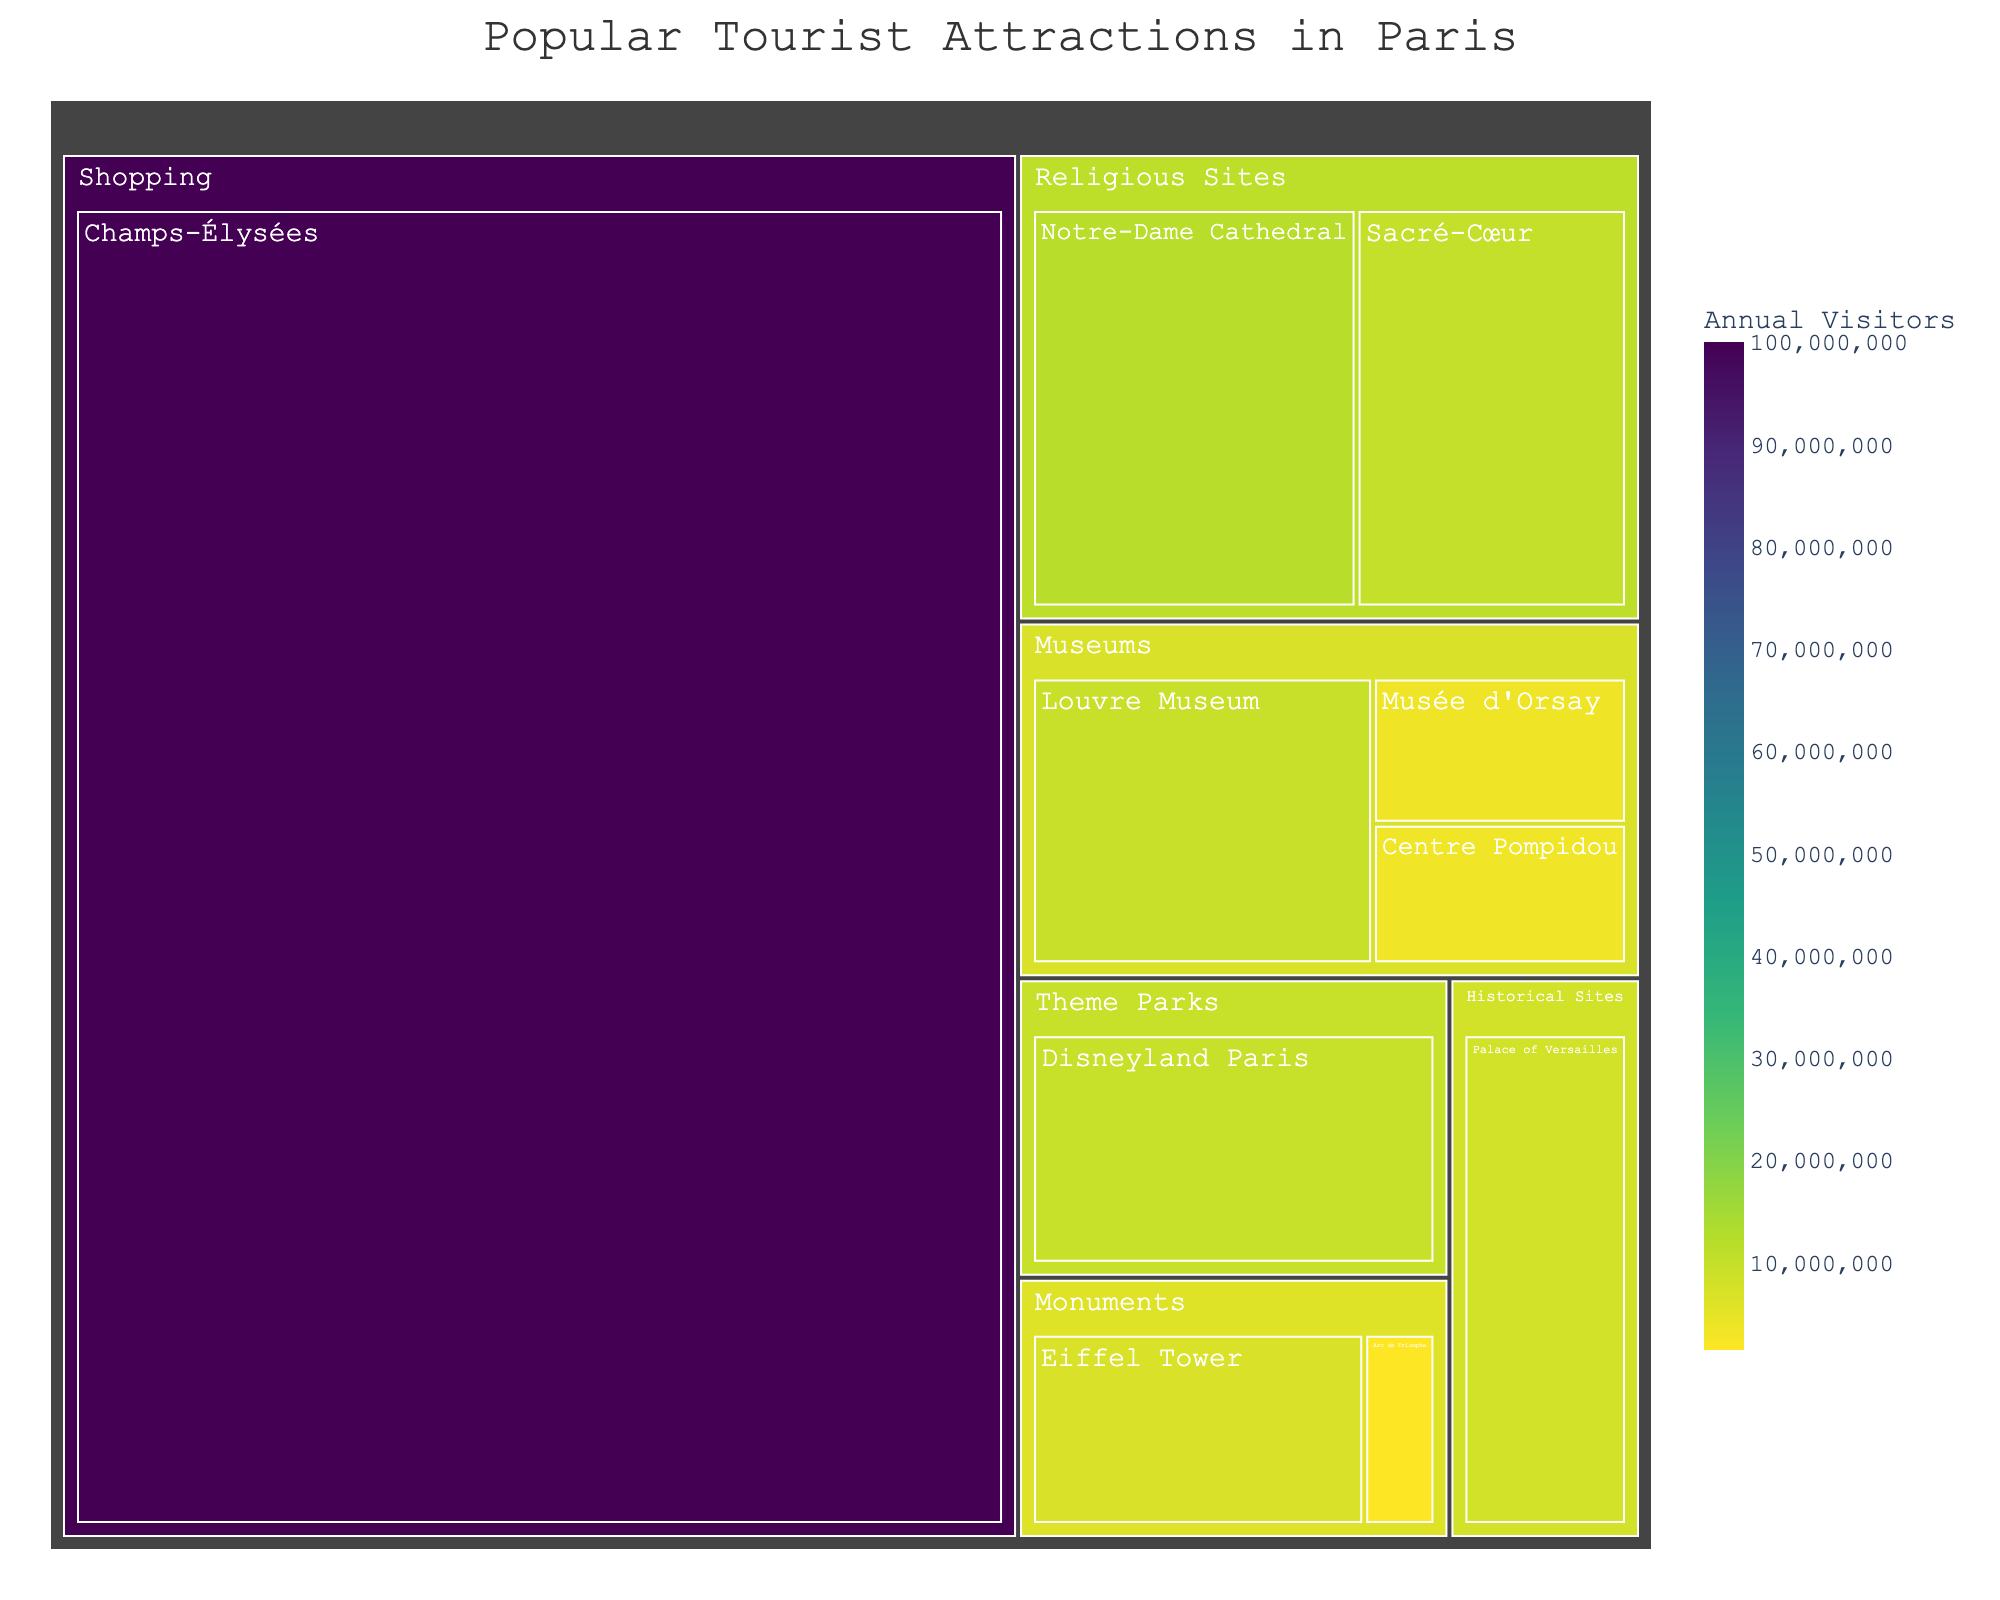What is the title of the treemap? The title of the treemap is placed prominently at the top center of the figure. Reading it directly gives the title.
Answer: Popular Tourist Attractions in Paris Which tourist attraction has the highest number of visitors? Check the boxes in the treemap for the largest area as larger areas represent higher values. Look for the label with the largest visitor number.
Answer: Champs-Élysées How many visitors does the Louvre Museum attract annually? Locate the box labeled Louvre Museum within the Museums category. The number of visitors is displayed on hover or written in the box.
Answer: 9,600,000 Which category occupies the largest area in the treemap? Categories in a treemap are represented by large boxes surrounding smaller boxes of the attractions. The biggest category box indicates the largest area.
Answer: Shopping Compare the number of annual visitors to Disneyland Paris and the Palace of Versailles. Which one gets more visitors? Find both Disneyland Paris and Palace of Versailles in the treemap and compare their visitor numbers. The one with a larger number has more visitors.
Answer: Disneyland Paris What is the combined visitor count for the Sacré-Cœur and Notre-Dame Cathedral? Sum the visitor numbers for Sacré-Cœur and Notre-Dame Cathedral from the Religious Sites category.
Answer: 22,000,000 What is the smallest attraction in terms of visitor numbers? Determine the smallest box within all categories by visitor count. The smallest box represents the attraction with the least visitors.
Answer: Arc de Triomphe Which attractions fall under the 'Monuments' category, and what are their visitor numbers? Identify the attractions within the Monuments category box. Check their individual visitor numbers, which are displayed either in the box or on hover.
Answer: Eiffel Tower: 7,000,000 
Arc de Triomphe: 1,500,000 Find the difference in visitor numbers between the Musée d'Orsay and the Centre Pompidou. Locate Musée d'Orsay and Centre Pompidou under the Museums category. Subtract the visitor count of Centre Pompidou from that of Musée d'Orsay.
Answer: 150,000 Which category has the second most visitors and what is the main attraction in that category? Identify the categories first and rank them by their total visitor counts. The one with the second highest total is the answer, and then identify its main attraction by the biggest box.
Answer: Religious Sites; Sacré-Cœur 